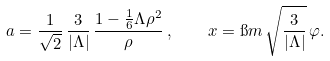<formula> <loc_0><loc_0><loc_500><loc_500>a = \frac { 1 } { \sqrt { 2 } } \, \frac { 3 } { | \Lambda | } \, \frac { 1 - \frac { 1 } { 6 } \Lambda \rho ^ { 2 } } { \rho } \, , \quad x = \i m \, \sqrt { \frac { 3 } { | \Lambda | } } \, \varphi .</formula> 